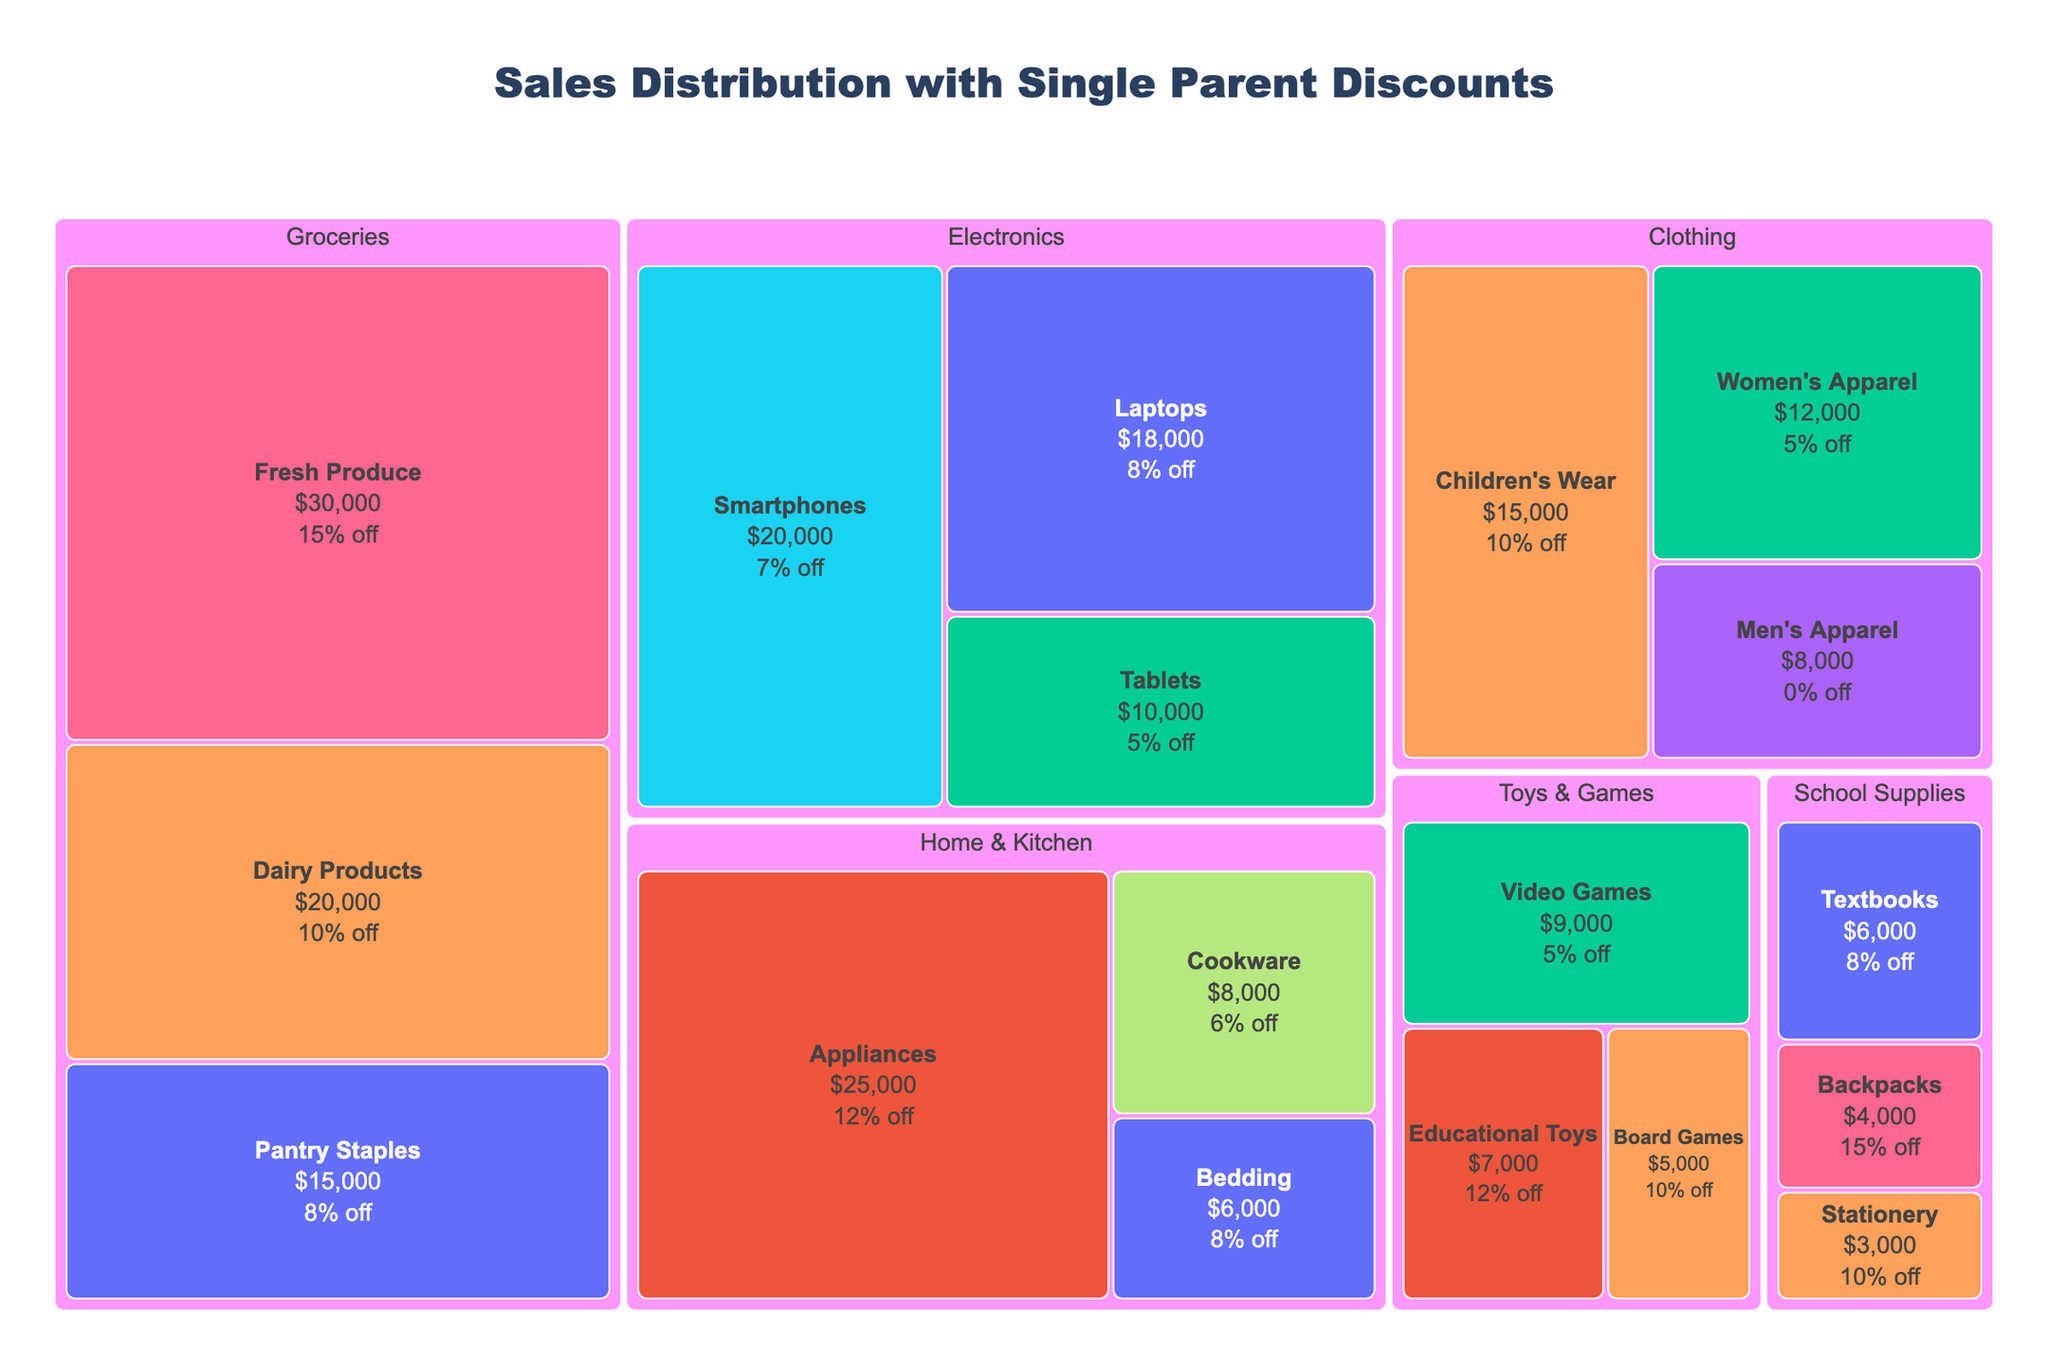What is the category with the highest sales value? The category with the highest total sales value can be identified by observing the area of the largest segment in the Treemap. In this case, "Groceries" has the largest area, indicating the highest sales value.
Answer: Groceries Which subcategory within "Home & Kitchen" offers the highest single parent discount? By looking within the "Home & Kitchen" category, identify the subcategory with the largest percentage label indicating the discount. "Appliances" offers a 12% discount, the highest within this category.
Answer: Appliances What is the total sales value for the "Electronics" category? Add the sales values for all subcategories under "Electronics": Smartphones ($20,000), Laptops ($18,000), and Tablets ($10,000). Summing these provides the total sales value.
Answer: $48,000 How does the sales value of "Children's Wear" compare to "Women's Apparel"? Look at the sales value for both "Children's Wear" and "Women's Apparel" within the "Clothing" category: Children's Wear ($15,000) and Women's Apparel ($12,000). Compare the numbers.
Answer: Children's Wear has higher sales What is the single parent discount percentage for "Textbooks" under "School Supplies"? Hover over or refer to the label for "Textbooks" within the "School Supplies" category. It shows an 8% discount.
Answer: 8% How does the size of the "Fresh Produce" section compare with "Pantry Staples" in the "Groceries" category visually? Based on the relative area size, "Fresh Produce" has a larger section compared to "Pantry Staples," indicating higher sales value.
Answer: Fresh Produce is larger What is the average discount rate for all subcategories within "Toys & Games"? Calculate the discounts for all subcategories: Educational Toys (12%), Board Games (10%), and Video Games (5%). The average is (12% + 10% + 5%) / 3.
Answer: 9% Which category appears to provide the most significant discount to single parents overall? Observing the color intensity and comparing the highest percentage values across categories, "Groceries" offers a 15% discount, the largest overall.
Answer: Groceries How many subcategories offer at least a 10% discount? Count all subcategories with discounts of 10% or more: Children's Wear (10%), Fresh Produce (15%), Dairy Products (10%), Pantry Staples (8%), Educational Toys (12%), Board Games (10%), Backpacks (15%), Stationery (10%).
Answer: 8 